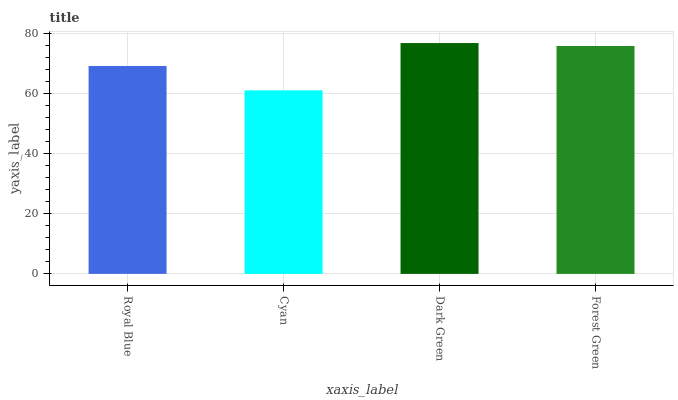Is Dark Green the minimum?
Answer yes or no. No. Is Cyan the maximum?
Answer yes or no. No. Is Dark Green greater than Cyan?
Answer yes or no. Yes. Is Cyan less than Dark Green?
Answer yes or no. Yes. Is Cyan greater than Dark Green?
Answer yes or no. No. Is Dark Green less than Cyan?
Answer yes or no. No. Is Forest Green the high median?
Answer yes or no. Yes. Is Royal Blue the low median?
Answer yes or no. Yes. Is Royal Blue the high median?
Answer yes or no. No. Is Dark Green the low median?
Answer yes or no. No. 